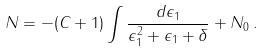<formula> <loc_0><loc_0><loc_500><loc_500>N = - ( C + 1 ) \int \frac { d \epsilon _ { 1 } } { \epsilon _ { 1 } ^ { 2 } + \epsilon _ { 1 } + \delta } + N _ { 0 } \, .</formula> 